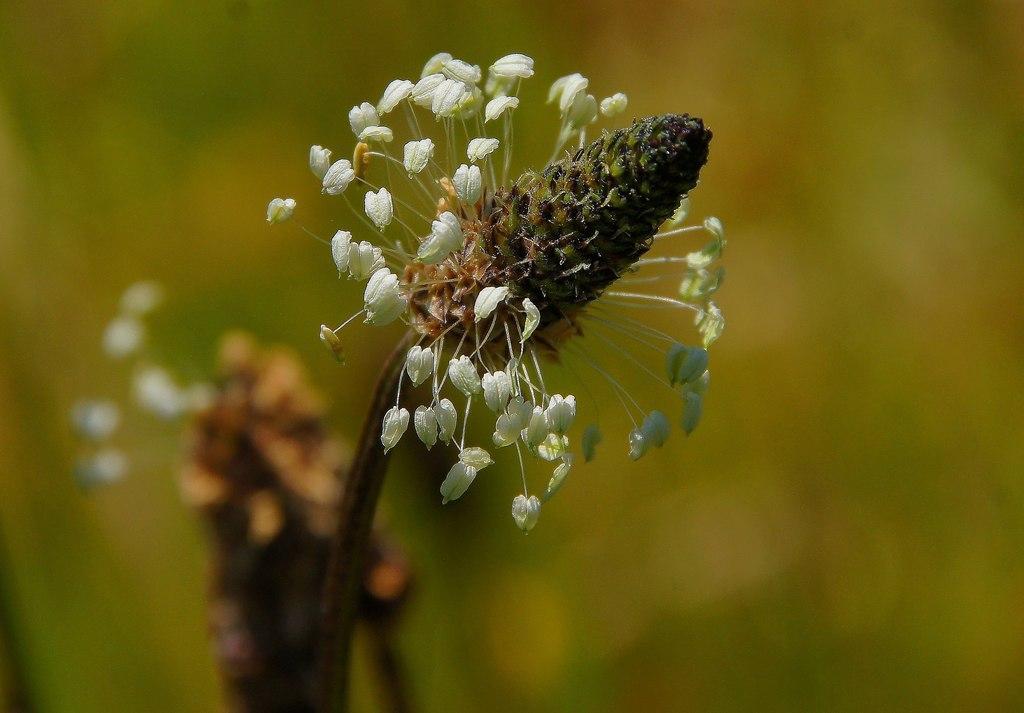Could you give a brief overview of what you see in this image? In the middle of this image, there is a flower of a plant. And the background is blurred. 